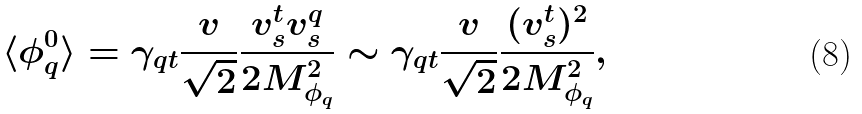<formula> <loc_0><loc_0><loc_500><loc_500>\langle \phi ^ { 0 } _ { q } \rangle = \gamma _ { q t } \frac { v } { \sqrt { 2 } } \frac { v ^ { t } _ { s } v ^ { q } _ { s } } { 2 M _ { \phi _ { q } } ^ { 2 } } \sim \gamma _ { q t } \frac { v } { \sqrt { 2 } } \frac { ( v ^ { t } _ { s } ) ^ { 2 } } { 2 M _ { \phi _ { q } } ^ { 2 } } ,</formula> 